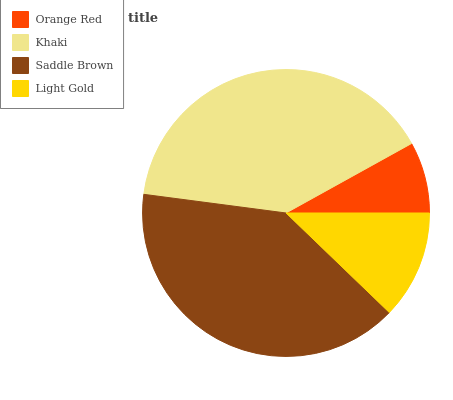Is Orange Red the minimum?
Answer yes or no. Yes. Is Khaki the maximum?
Answer yes or no. Yes. Is Saddle Brown the minimum?
Answer yes or no. No. Is Saddle Brown the maximum?
Answer yes or no. No. Is Khaki greater than Saddle Brown?
Answer yes or no. Yes. Is Saddle Brown less than Khaki?
Answer yes or no. Yes. Is Saddle Brown greater than Khaki?
Answer yes or no. No. Is Khaki less than Saddle Brown?
Answer yes or no. No. Is Saddle Brown the high median?
Answer yes or no. Yes. Is Light Gold the low median?
Answer yes or no. Yes. Is Khaki the high median?
Answer yes or no. No. Is Orange Red the low median?
Answer yes or no. No. 